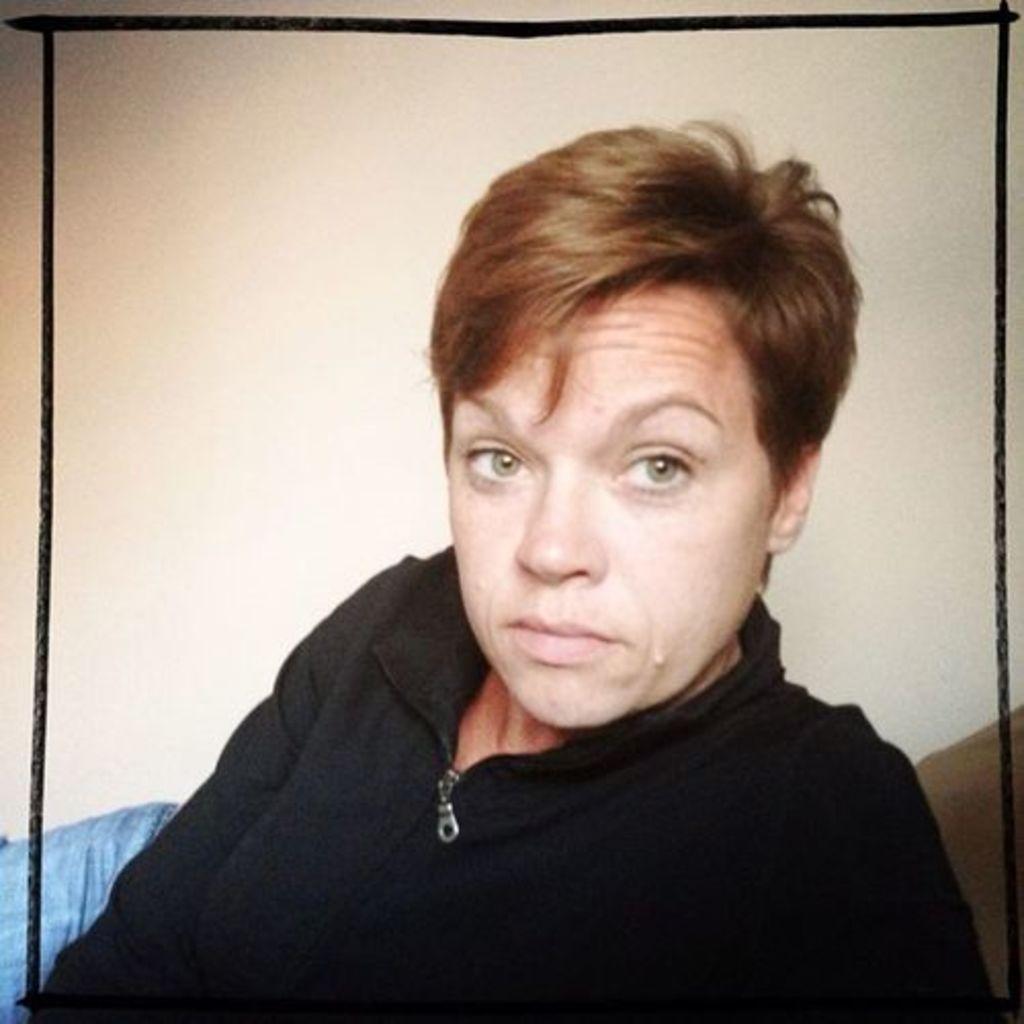Could you give a brief overview of what you see in this image? In this picture there is a man who is wearing black jacket. He is sitting on the couch. In the back there's a wall. On the bottom left corner we can see a person's leg who is wearing jeans. 